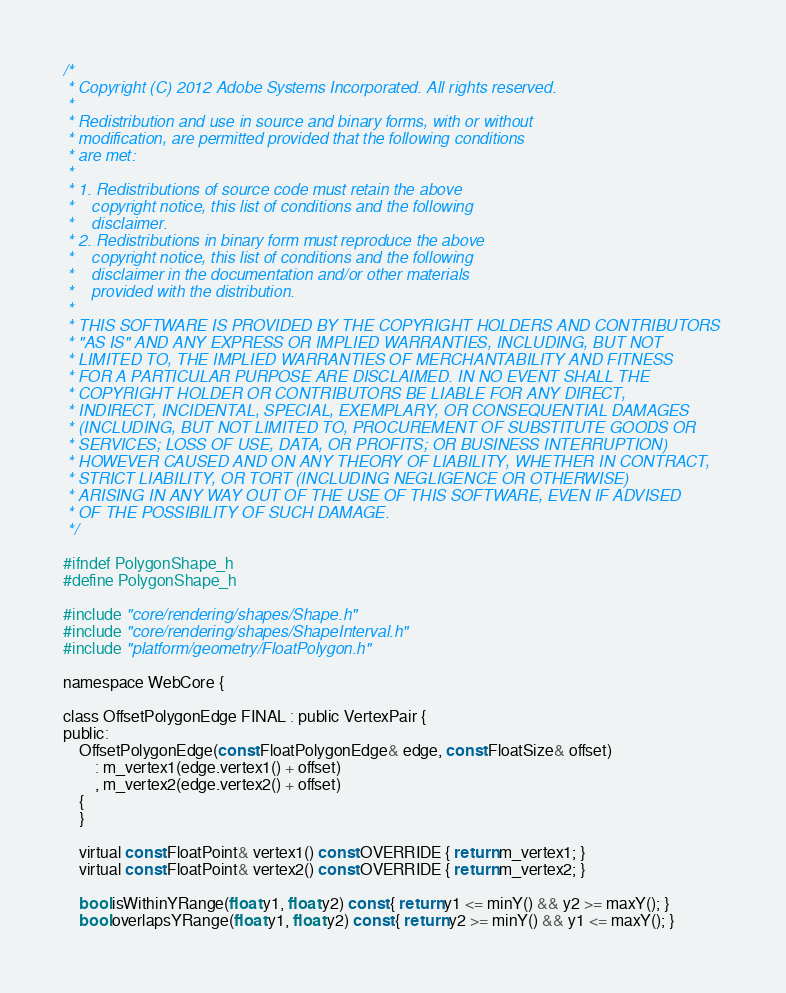<code> <loc_0><loc_0><loc_500><loc_500><_C_>/*
 * Copyright (C) 2012 Adobe Systems Incorporated. All rights reserved.
 *
 * Redistribution and use in source and binary forms, with or without
 * modification, are permitted provided that the following conditions
 * are met:
 *
 * 1. Redistributions of source code must retain the above
 *    copyright notice, this list of conditions and the following
 *    disclaimer.
 * 2. Redistributions in binary form must reproduce the above
 *    copyright notice, this list of conditions and the following
 *    disclaimer in the documentation and/or other materials
 *    provided with the distribution.
 *
 * THIS SOFTWARE IS PROVIDED BY THE COPYRIGHT HOLDERS AND CONTRIBUTORS
 * "AS IS" AND ANY EXPRESS OR IMPLIED WARRANTIES, INCLUDING, BUT NOT
 * LIMITED TO, THE IMPLIED WARRANTIES OF MERCHANTABILITY AND FITNESS
 * FOR A PARTICULAR PURPOSE ARE DISCLAIMED. IN NO EVENT SHALL THE
 * COPYRIGHT HOLDER OR CONTRIBUTORS BE LIABLE FOR ANY DIRECT,
 * INDIRECT, INCIDENTAL, SPECIAL, EXEMPLARY, OR CONSEQUENTIAL DAMAGES
 * (INCLUDING, BUT NOT LIMITED TO, PROCUREMENT OF SUBSTITUTE GOODS OR
 * SERVICES; LOSS OF USE, DATA, OR PROFITS; OR BUSINESS INTERRUPTION)
 * HOWEVER CAUSED AND ON ANY THEORY OF LIABILITY, WHETHER IN CONTRACT,
 * STRICT LIABILITY, OR TORT (INCLUDING NEGLIGENCE OR OTHERWISE)
 * ARISING IN ANY WAY OUT OF THE USE OF THIS SOFTWARE, EVEN IF ADVISED
 * OF THE POSSIBILITY OF SUCH DAMAGE.
 */

#ifndef PolygonShape_h
#define PolygonShape_h

#include "core/rendering/shapes/Shape.h"
#include "core/rendering/shapes/ShapeInterval.h"
#include "platform/geometry/FloatPolygon.h"

namespace WebCore {

class OffsetPolygonEdge FINAL : public VertexPair {
public:
    OffsetPolygonEdge(const FloatPolygonEdge& edge, const FloatSize& offset)
        : m_vertex1(edge.vertex1() + offset)
        , m_vertex2(edge.vertex2() + offset)
    {
    }

    virtual const FloatPoint& vertex1() const OVERRIDE { return m_vertex1; }
    virtual const FloatPoint& vertex2() const OVERRIDE { return m_vertex2; }

    bool isWithinYRange(float y1, float y2) const { return y1 <= minY() && y2 >= maxY(); }
    bool overlapsYRange(float y1, float y2) const { return y2 >= minY() && y1 <= maxY(); }</code> 